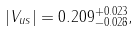Convert formula to latex. <formula><loc_0><loc_0><loc_500><loc_500>| V _ { u s } | = 0 . 2 0 9 ^ { + 0 . 0 2 3 } _ { - 0 . 0 2 8 } ,</formula> 